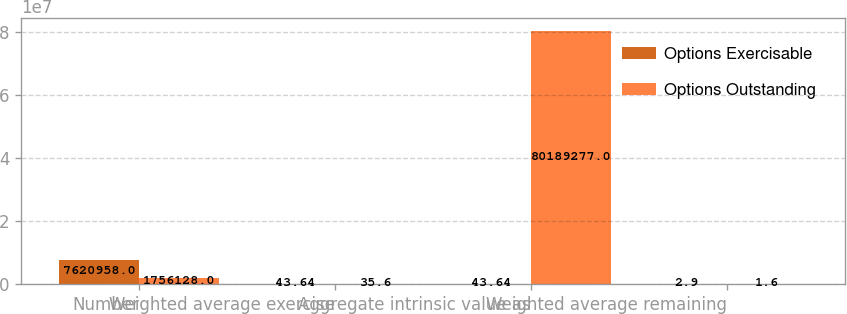<chart> <loc_0><loc_0><loc_500><loc_500><stacked_bar_chart><ecel><fcel>Number<fcel>Weighted average exercise<fcel>Aggregate intrinsic value as<fcel>Weighted average remaining<nl><fcel>Options Exercisable<fcel>7.62096e+06<fcel>43.64<fcel>43.64<fcel>2.9<nl><fcel>Options Outstanding<fcel>1.75613e+06<fcel>35.6<fcel>8.01893e+07<fcel>1.6<nl></chart> 